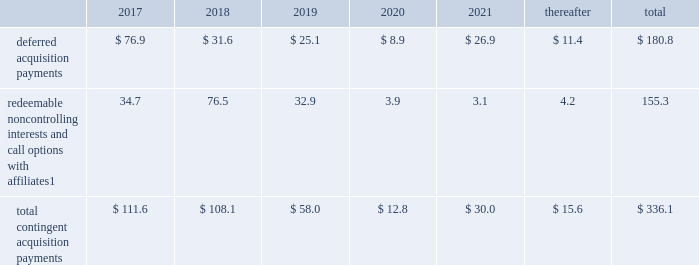Notes to consolidated financial statements 2013 ( continued ) ( amounts in millions , except per share amounts ) guarantees we have guaranteed certain obligations of our subsidiaries relating principally to operating leases and credit facilities of certain subsidiaries .
The amount of parent company guarantees on lease obligations was $ 857.3 and $ 619.4 as of december 31 , 2016 and 2015 , respectively , and the amount of parent company guarantees primarily relating to credit facilities was $ 395.6 and $ 336.5 as of december 31 , 2016 and 2015 , respectively .
In the event of non-payment by the applicable subsidiary of the obligations covered by a guarantee , we would be obligated to pay the amounts covered by that guarantee .
As of december 31 , 2016 , there were no material assets pledged as security for such parent company guarantees .
Contingent acquisition obligations the table details the estimated future contingent acquisition obligations payable in cash as of december 31 .
1 we have entered into certain acquisitions that contain both redeemable noncontrolling interests and call options with similar terms and conditions .
The estimated amounts listed would be paid in the event of exercise at the earliest exercise date .
We have certain redeemable noncontrolling interests that are exercisable at the discretion of the noncontrolling equity owners as of december 31 , 2016 .
These estimated payments of $ 25.9 are included within the total payments expected to be made in 2017 , and will continue to be carried forward into 2018 or beyond until exercised or expired .
Redeemable noncontrolling interests are included in the table at current exercise price payable in cash , not at applicable redemption value in accordance with the authoritative guidance for classification and measurement of redeemable securities .
The majority of these payments are contingent upon achieving projected operating performance targets and satisfying other conditions specified in the related agreements and are subject to revision in accordance with the terms of the respective agreements .
See note 4 for further information relating to the payment structure of our acquisitions .
Legal matters in the normal course of business , we are involved in various legal proceedings , and subject to investigations , inspections , audits , inquiries and similar actions by governmental authorities .
The types of allegations that arise in connection with such legal proceedings vary in nature , but can include claims related to contract , employment , tax and intellectual property matters .
We evaluate all cases each reporting period and record liabilities for losses from legal proceedings when we determine that it is probable that the outcome in a legal proceeding will be unfavorable and the amount , or potential range , of loss can be reasonably estimated .
In certain cases , we cannot reasonably estimate the potential loss because , for example , the litigation is in its early stages .
While any outcome related to litigation or such governmental proceedings in which we are involved cannot be predicted with certainty , management believes that the outcome of these matters , individually and in the aggregate , will not have a material adverse effect on our financial condition , results of operations or cash flows .
As previously disclosed , on april 10 , 2015 , a federal judge in brazil authorized the search of the records of an agency 2019s offices in s e3o paulo and brasilia , in connection with an ongoing investigation by brazilian authorities involving payments potentially connected to local government contracts .
The company had previously investigated the matter and taken a number of remedial and disciplinary actions .
The company is in the process of concluding a settlement related to these matters with government agencies .
The company confirmed that one of its standalone domestic agencies has been contacted by the department of justice antitrust division for documents regarding video production practices and is cooperating with the government. .
What is the total amount guaranteed by the parent company in 2016? 
Computations: (857.3 + 395.6)
Answer: 1252.9. Notes to consolidated financial statements 2013 ( continued ) ( amounts in millions , except per share amounts ) guarantees we have guaranteed certain obligations of our subsidiaries relating principally to operating leases and credit facilities of certain subsidiaries .
The amount of parent company guarantees on lease obligations was $ 857.3 and $ 619.4 as of december 31 , 2016 and 2015 , respectively , and the amount of parent company guarantees primarily relating to credit facilities was $ 395.6 and $ 336.5 as of december 31 , 2016 and 2015 , respectively .
In the event of non-payment by the applicable subsidiary of the obligations covered by a guarantee , we would be obligated to pay the amounts covered by that guarantee .
As of december 31 , 2016 , there were no material assets pledged as security for such parent company guarantees .
Contingent acquisition obligations the table details the estimated future contingent acquisition obligations payable in cash as of december 31 .
1 we have entered into certain acquisitions that contain both redeemable noncontrolling interests and call options with similar terms and conditions .
The estimated amounts listed would be paid in the event of exercise at the earliest exercise date .
We have certain redeemable noncontrolling interests that are exercisable at the discretion of the noncontrolling equity owners as of december 31 , 2016 .
These estimated payments of $ 25.9 are included within the total payments expected to be made in 2017 , and will continue to be carried forward into 2018 or beyond until exercised or expired .
Redeemable noncontrolling interests are included in the table at current exercise price payable in cash , not at applicable redemption value in accordance with the authoritative guidance for classification and measurement of redeemable securities .
The majority of these payments are contingent upon achieving projected operating performance targets and satisfying other conditions specified in the related agreements and are subject to revision in accordance with the terms of the respective agreements .
See note 4 for further information relating to the payment structure of our acquisitions .
Legal matters in the normal course of business , we are involved in various legal proceedings , and subject to investigations , inspections , audits , inquiries and similar actions by governmental authorities .
The types of allegations that arise in connection with such legal proceedings vary in nature , but can include claims related to contract , employment , tax and intellectual property matters .
We evaluate all cases each reporting period and record liabilities for losses from legal proceedings when we determine that it is probable that the outcome in a legal proceeding will be unfavorable and the amount , or potential range , of loss can be reasonably estimated .
In certain cases , we cannot reasonably estimate the potential loss because , for example , the litigation is in its early stages .
While any outcome related to litigation or such governmental proceedings in which we are involved cannot be predicted with certainty , management believes that the outcome of these matters , individually and in the aggregate , will not have a material adverse effect on our financial condition , results of operations or cash flows .
As previously disclosed , on april 10 , 2015 , a federal judge in brazil authorized the search of the records of an agency 2019s offices in s e3o paulo and brasilia , in connection with an ongoing investigation by brazilian authorities involving payments potentially connected to local government contracts .
The company had previously investigated the matter and taken a number of remedial and disciplinary actions .
The company is in the process of concluding a settlement related to these matters with government agencies .
The company confirmed that one of its standalone domestic agencies has been contacted by the department of justice antitrust division for documents regarding video production practices and is cooperating with the government. .
What portion of total contingent acquisition payments is used for redeemable noncontrolling interests and call options? 
Computations: (155.3 / 336.1)
Answer: 0.46206. 